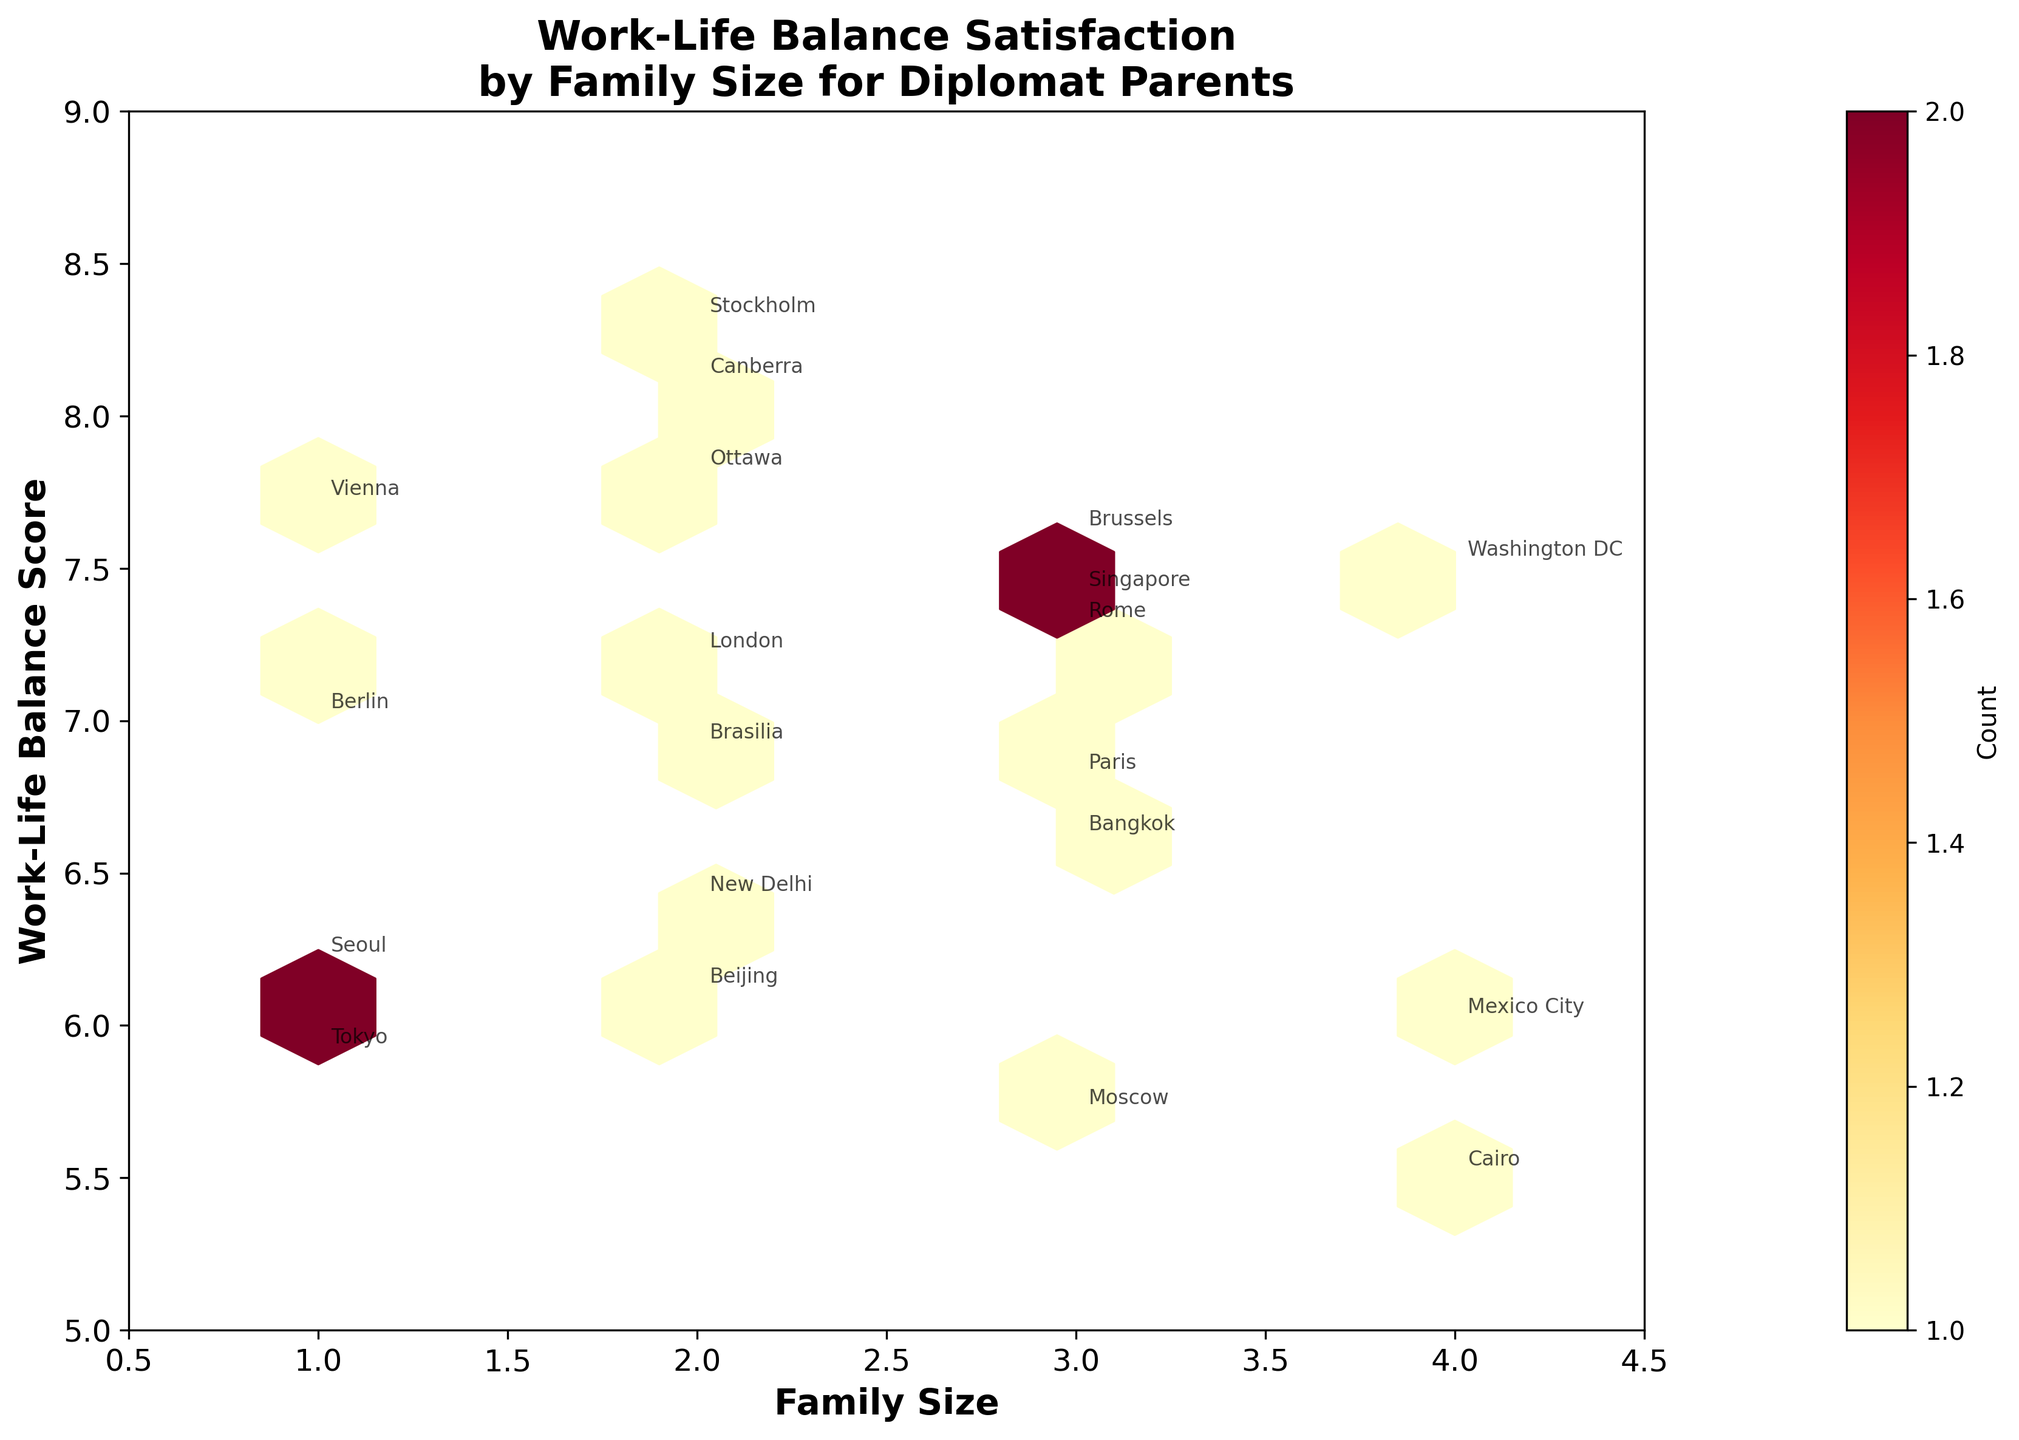What is the title of the figure? The title is usually at the top of the plot. For this plot, the title is "Work-Life Balance Satisfaction\nby Family Size for Diplomat Parents".
Answer: Work-Life Balance Satisfaction\nby Family Size for Diplomat Parents What are the x and y axes labeled as? The labels of the axes provide context for the data being plotted. The x-axis is labeled as "Family Size" and the y-axis as "Work-Life Balance Score".
Answer: Family Size, Work-Life Balance Score Which posting location has the highest work-life balance score? Look for the highest y-value on the plot and find the corresponding data point annotation. "Stockholm" has the highest work-life balance score of 8.3.
Answer: Stockholm How many data points are there in the figure? Each point is an instance where a family in a certain posting location has a specific family size and work-life balance score. Count the number of annotations. There are 19 posting locations listed.
Answer: 19 Which family size appears to have the highest concentration of work-life balance scores? The color intensity in the hexagonal bins indicates the concentration. Look for the bins with the highest intensity. Family size 2 appears to have the highest concentration.
Answer: Family size 2 What is the average work-life balance score for families with a size of 3? Identify the work-life balance scores for family size 3: 6.8 (Paris), 5.7 (Moscow), 7.3 (Rome), 7.6 (Brussels), 7.4 (Singapore), 6.6 (Bangkok). Calculate the average: (6.8 + 5.7 + 7.3 + 7.6 + 7.4 + 6.6) / 6 = 6.9.
Answer: 6.9 For families located in Washington DC, what is their family size and work-life balance score? Look at the annotations to find Washington DC, then check its position on the x and y axes. Washington DC has a family size of 4 and a work-life balance score of 7.5.
Answer: Family size 4, work-life balance score 7.5 Which posting location has a family size of 4 and the lowest work-life balance score? Look at the data points annotated with a family size of 4. Identify the one with the lowest y-value. Cairo has a family size of 4 and a work-life balance score of 5.5, which is the lowest among families of size 4.
Answer: Cairo What is the family size and work-life balance score for the posting location "Berlin"? Find the annotation for Berlin and read the x and y values associated with it. Berlin has a family size of 1 and work-life balance score of 7.0.
Answer: Family size 1, work-life balance score 7.0 